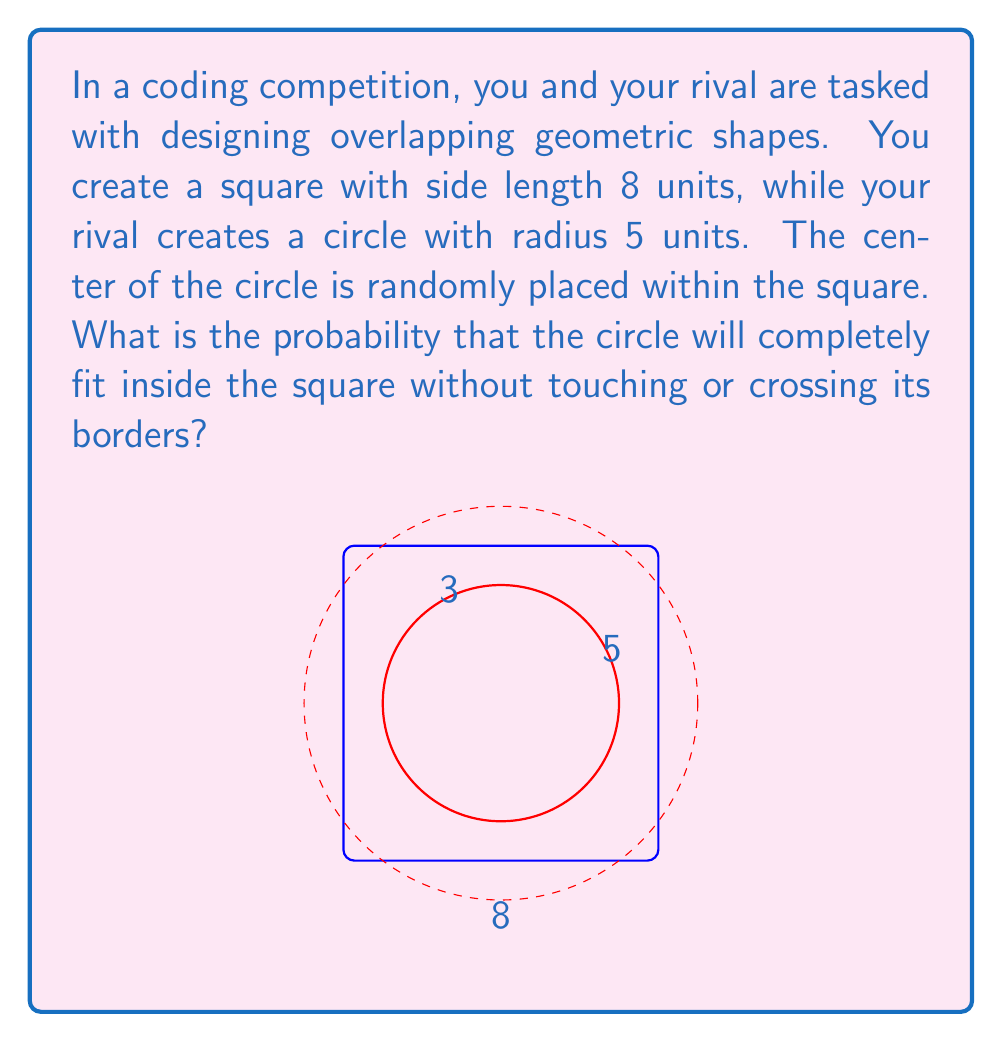Teach me how to tackle this problem. Let's approach this step-by-step:

1) For the circle to fit completely inside the square, its center must be at least 5 units (the radius) away from all sides of the square.

2) This creates a smaller square within the original square where the center of the circle can be placed. Let's call the side length of this smaller square $x$.

3) The side length of the smaller square can be calculated as:
   $x = 8 - 2(5) = 8 - 10 = -2$

4) However, a negative length is impossible. This means that the circle with radius 5 is too large to fit completely inside the square in any position.

5) To find a circle that could fit, we need to solve:
   $8 - 2r > 0$
   $-2r > -8$
   $r < 4$

6) The largest circle that could fit would have a radius of 3 units (as shown in the figure).

7) Since no valid placements exist for the given circle, the probability is 0.
Answer: 0 